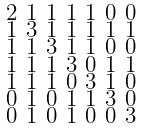Convert formula to latex. <formula><loc_0><loc_0><loc_500><loc_500>\begin{smallmatrix} 2 & 1 & 1 & 1 & 1 & 0 & 0 \\ 1 & 3 & 1 & 1 & 1 & 1 & 1 \\ 1 & 1 & 3 & 1 & 1 & 0 & 0 \\ 1 & 1 & 1 & 3 & 0 & 1 & 1 \\ 1 & 1 & 1 & 0 & 3 & 1 & 0 \\ 0 & 1 & 0 & 1 & 1 & 3 & 0 \\ 0 & 1 & 0 & 1 & 0 & 0 & 3 \end{smallmatrix}</formula> 